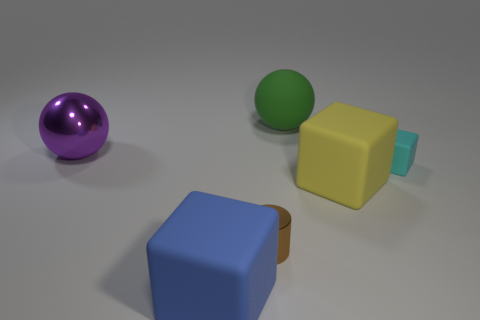There is a thing left of the large object in front of the small metal cylinder; are there any brown shiny cylinders in front of it?
Provide a short and direct response. Yes. How many metal objects are small things or yellow cubes?
Your answer should be very brief. 1. What number of other things are the same shape as the tiny shiny object?
Keep it short and to the point. 0. Is the number of cyan matte cubes greater than the number of large brown metal cylinders?
Provide a succinct answer. Yes. What is the size of the rubber block that is in front of the large yellow matte object on the right side of the tiny object that is in front of the cyan block?
Provide a short and direct response. Large. There is a sphere that is on the right side of the brown object; what is its size?
Provide a short and direct response. Large. How many things are either large red blocks or rubber blocks in front of the small cyan rubber block?
Your answer should be very brief. 2. How many other objects are there of the same size as the shiny cylinder?
Ensure brevity in your answer.  1. There is another large thing that is the same shape as the big green object; what is it made of?
Give a very brief answer. Metal. Is the number of matte things that are on the left side of the small cube greater than the number of tiny metal objects?
Provide a short and direct response. Yes. 